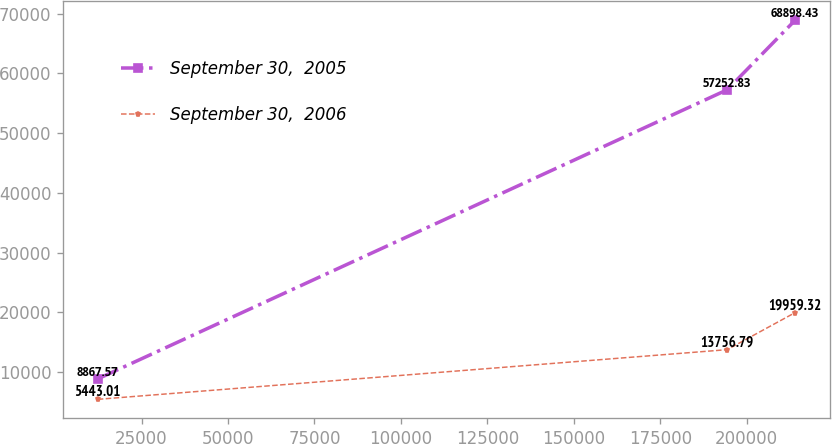Convert chart. <chart><loc_0><loc_0><loc_500><loc_500><line_chart><ecel><fcel>September 30,  2005<fcel>September 30,  2006<nl><fcel>12350.3<fcel>8867.57<fcel>5443.01<nl><fcel>194359<fcel>57252.8<fcel>13756.8<nl><fcel>214014<fcel>68898.4<fcel>19959.3<nl></chart> 